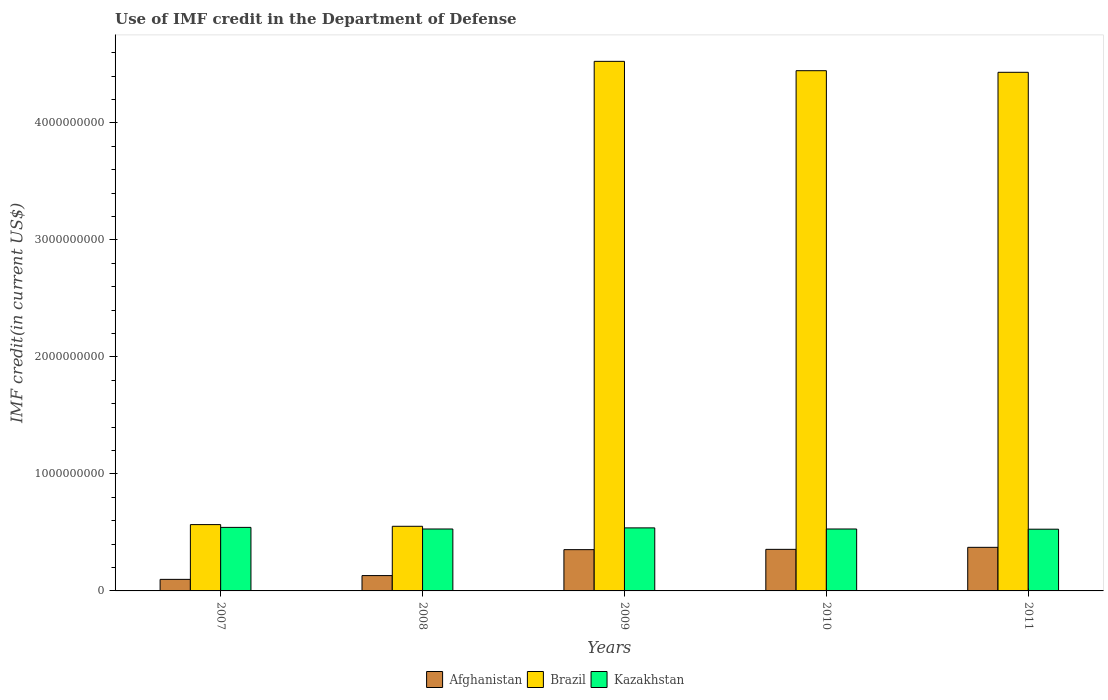Are the number of bars per tick equal to the number of legend labels?
Offer a very short reply. Yes. Are the number of bars on each tick of the X-axis equal?
Your answer should be very brief. Yes. What is the label of the 5th group of bars from the left?
Make the answer very short. 2011. In how many cases, is the number of bars for a given year not equal to the number of legend labels?
Provide a succinct answer. 0. What is the IMF credit in the Department of Defense in Afghanistan in 2007?
Your response must be concise. 9.88e+07. Across all years, what is the maximum IMF credit in the Department of Defense in Afghanistan?
Provide a succinct answer. 3.73e+08. Across all years, what is the minimum IMF credit in the Department of Defense in Brazil?
Your answer should be compact. 5.52e+08. What is the total IMF credit in the Department of Defense in Brazil in the graph?
Offer a very short reply. 1.45e+1. What is the difference between the IMF credit in the Department of Defense in Brazil in 2010 and that in 2011?
Give a very brief answer. 1.37e+07. What is the difference between the IMF credit in the Department of Defense in Brazil in 2007 and the IMF credit in the Department of Defense in Kazakhstan in 2010?
Make the answer very short. 3.76e+07. What is the average IMF credit in the Department of Defense in Afghanistan per year?
Make the answer very short. 2.62e+08. In the year 2010, what is the difference between the IMF credit in the Department of Defense in Afghanistan and IMF credit in the Department of Defense in Brazil?
Keep it short and to the point. -4.09e+09. What is the ratio of the IMF credit in the Department of Defense in Kazakhstan in 2007 to that in 2011?
Your answer should be compact. 1.03. Is the difference between the IMF credit in the Department of Defense in Afghanistan in 2010 and 2011 greater than the difference between the IMF credit in the Department of Defense in Brazil in 2010 and 2011?
Your answer should be compact. No. What is the difference between the highest and the second highest IMF credit in the Department of Defense in Afghanistan?
Your response must be concise. 1.73e+07. What is the difference between the highest and the lowest IMF credit in the Department of Defense in Afghanistan?
Provide a short and direct response. 2.74e+08. What does the 1st bar from the left in 2009 represents?
Offer a terse response. Afghanistan. What does the 3rd bar from the right in 2007 represents?
Offer a terse response. Afghanistan. Is it the case that in every year, the sum of the IMF credit in the Department of Defense in Afghanistan and IMF credit in the Department of Defense in Brazil is greater than the IMF credit in the Department of Defense in Kazakhstan?
Keep it short and to the point. Yes. How many bars are there?
Your answer should be compact. 15. How many years are there in the graph?
Your answer should be compact. 5. Does the graph contain any zero values?
Provide a short and direct response. No. How are the legend labels stacked?
Keep it short and to the point. Horizontal. What is the title of the graph?
Provide a succinct answer. Use of IMF credit in the Department of Defense. Does "South Sudan" appear as one of the legend labels in the graph?
Offer a very short reply. No. What is the label or title of the X-axis?
Offer a very short reply. Years. What is the label or title of the Y-axis?
Provide a short and direct response. IMF credit(in current US$). What is the IMF credit(in current US$) in Afghanistan in 2007?
Provide a succinct answer. 9.88e+07. What is the IMF credit(in current US$) in Brazil in 2007?
Provide a succinct answer. 5.67e+08. What is the IMF credit(in current US$) of Kazakhstan in 2007?
Give a very brief answer. 5.43e+08. What is the IMF credit(in current US$) in Afghanistan in 2008?
Your response must be concise. 1.31e+08. What is the IMF credit(in current US$) of Brazil in 2008?
Make the answer very short. 5.52e+08. What is the IMF credit(in current US$) of Kazakhstan in 2008?
Provide a short and direct response. 5.29e+08. What is the IMF credit(in current US$) in Afghanistan in 2009?
Provide a succinct answer. 3.53e+08. What is the IMF credit(in current US$) of Brazil in 2009?
Keep it short and to the point. 4.53e+09. What is the IMF credit(in current US$) of Kazakhstan in 2009?
Your answer should be compact. 5.39e+08. What is the IMF credit(in current US$) of Afghanistan in 2010?
Your answer should be very brief. 3.55e+08. What is the IMF credit(in current US$) in Brazil in 2010?
Your response must be concise. 4.45e+09. What is the IMF credit(in current US$) of Kazakhstan in 2010?
Your answer should be very brief. 5.29e+08. What is the IMF credit(in current US$) of Afghanistan in 2011?
Provide a short and direct response. 3.73e+08. What is the IMF credit(in current US$) of Brazil in 2011?
Offer a very short reply. 4.43e+09. What is the IMF credit(in current US$) in Kazakhstan in 2011?
Provide a short and direct response. 5.28e+08. Across all years, what is the maximum IMF credit(in current US$) of Afghanistan?
Your answer should be compact. 3.73e+08. Across all years, what is the maximum IMF credit(in current US$) of Brazil?
Your answer should be compact. 4.53e+09. Across all years, what is the maximum IMF credit(in current US$) of Kazakhstan?
Your answer should be very brief. 5.43e+08. Across all years, what is the minimum IMF credit(in current US$) of Afghanistan?
Your answer should be compact. 9.88e+07. Across all years, what is the minimum IMF credit(in current US$) of Brazil?
Offer a very short reply. 5.52e+08. Across all years, what is the minimum IMF credit(in current US$) of Kazakhstan?
Your answer should be compact. 5.28e+08. What is the total IMF credit(in current US$) of Afghanistan in the graph?
Ensure brevity in your answer.  1.31e+09. What is the total IMF credit(in current US$) of Brazil in the graph?
Your answer should be very brief. 1.45e+1. What is the total IMF credit(in current US$) of Kazakhstan in the graph?
Provide a short and direct response. 2.67e+09. What is the difference between the IMF credit(in current US$) of Afghanistan in 2007 and that in 2008?
Ensure brevity in your answer.  -3.23e+07. What is the difference between the IMF credit(in current US$) of Brazil in 2007 and that in 2008?
Keep it short and to the point. 1.43e+07. What is the difference between the IMF credit(in current US$) of Kazakhstan in 2007 and that in 2008?
Keep it short and to the point. 1.37e+07. What is the difference between the IMF credit(in current US$) in Afghanistan in 2007 and that in 2009?
Give a very brief answer. -2.54e+08. What is the difference between the IMF credit(in current US$) of Brazil in 2007 and that in 2009?
Your answer should be compact. -3.96e+09. What is the difference between the IMF credit(in current US$) of Kazakhstan in 2007 and that in 2009?
Provide a succinct answer. 4.32e+06. What is the difference between the IMF credit(in current US$) of Afghanistan in 2007 and that in 2010?
Your answer should be very brief. -2.56e+08. What is the difference between the IMF credit(in current US$) in Brazil in 2007 and that in 2010?
Offer a terse response. -3.88e+09. What is the difference between the IMF credit(in current US$) of Kazakhstan in 2007 and that in 2010?
Make the answer very short. 1.38e+07. What is the difference between the IMF credit(in current US$) in Afghanistan in 2007 and that in 2011?
Provide a succinct answer. -2.74e+08. What is the difference between the IMF credit(in current US$) in Brazil in 2007 and that in 2011?
Give a very brief answer. -3.87e+09. What is the difference between the IMF credit(in current US$) of Kazakhstan in 2007 and that in 2011?
Provide a succinct answer. 1.55e+07. What is the difference between the IMF credit(in current US$) in Afghanistan in 2008 and that in 2009?
Your response must be concise. -2.22e+08. What is the difference between the IMF credit(in current US$) of Brazil in 2008 and that in 2009?
Offer a terse response. -3.97e+09. What is the difference between the IMF credit(in current US$) of Kazakhstan in 2008 and that in 2009?
Make the answer very short. -9.42e+06. What is the difference between the IMF credit(in current US$) of Afghanistan in 2008 and that in 2010?
Offer a terse response. -2.24e+08. What is the difference between the IMF credit(in current US$) of Brazil in 2008 and that in 2010?
Make the answer very short. -3.89e+09. What is the difference between the IMF credit(in current US$) of Kazakhstan in 2008 and that in 2010?
Provide a short and direct response. 8.20e+04. What is the difference between the IMF credit(in current US$) of Afghanistan in 2008 and that in 2011?
Make the answer very short. -2.41e+08. What is the difference between the IMF credit(in current US$) of Brazil in 2008 and that in 2011?
Make the answer very short. -3.88e+09. What is the difference between the IMF credit(in current US$) of Kazakhstan in 2008 and that in 2011?
Ensure brevity in your answer.  1.72e+06. What is the difference between the IMF credit(in current US$) of Afghanistan in 2009 and that in 2010?
Offer a terse response. -2.48e+06. What is the difference between the IMF credit(in current US$) in Brazil in 2009 and that in 2010?
Keep it short and to the point. 7.99e+07. What is the difference between the IMF credit(in current US$) in Kazakhstan in 2009 and that in 2010?
Ensure brevity in your answer.  9.50e+06. What is the difference between the IMF credit(in current US$) in Afghanistan in 2009 and that in 2011?
Provide a succinct answer. -1.98e+07. What is the difference between the IMF credit(in current US$) in Brazil in 2009 and that in 2011?
Keep it short and to the point. 9.36e+07. What is the difference between the IMF credit(in current US$) of Kazakhstan in 2009 and that in 2011?
Ensure brevity in your answer.  1.11e+07. What is the difference between the IMF credit(in current US$) of Afghanistan in 2010 and that in 2011?
Give a very brief answer. -1.73e+07. What is the difference between the IMF credit(in current US$) of Brazil in 2010 and that in 2011?
Provide a short and direct response. 1.37e+07. What is the difference between the IMF credit(in current US$) in Kazakhstan in 2010 and that in 2011?
Give a very brief answer. 1.64e+06. What is the difference between the IMF credit(in current US$) of Afghanistan in 2007 and the IMF credit(in current US$) of Brazil in 2008?
Your answer should be compact. -4.54e+08. What is the difference between the IMF credit(in current US$) in Afghanistan in 2007 and the IMF credit(in current US$) in Kazakhstan in 2008?
Provide a short and direct response. -4.31e+08. What is the difference between the IMF credit(in current US$) in Brazil in 2007 and the IMF credit(in current US$) in Kazakhstan in 2008?
Give a very brief answer. 3.75e+07. What is the difference between the IMF credit(in current US$) in Afghanistan in 2007 and the IMF credit(in current US$) in Brazil in 2009?
Your answer should be very brief. -4.43e+09. What is the difference between the IMF credit(in current US$) of Afghanistan in 2007 and the IMF credit(in current US$) of Kazakhstan in 2009?
Offer a very short reply. -4.40e+08. What is the difference between the IMF credit(in current US$) in Brazil in 2007 and the IMF credit(in current US$) in Kazakhstan in 2009?
Make the answer very short. 2.80e+07. What is the difference between the IMF credit(in current US$) of Afghanistan in 2007 and the IMF credit(in current US$) of Brazil in 2010?
Your response must be concise. -4.35e+09. What is the difference between the IMF credit(in current US$) in Afghanistan in 2007 and the IMF credit(in current US$) in Kazakhstan in 2010?
Offer a terse response. -4.30e+08. What is the difference between the IMF credit(in current US$) in Brazil in 2007 and the IMF credit(in current US$) in Kazakhstan in 2010?
Your answer should be very brief. 3.76e+07. What is the difference between the IMF credit(in current US$) of Afghanistan in 2007 and the IMF credit(in current US$) of Brazil in 2011?
Keep it short and to the point. -4.33e+09. What is the difference between the IMF credit(in current US$) in Afghanistan in 2007 and the IMF credit(in current US$) in Kazakhstan in 2011?
Offer a very short reply. -4.29e+08. What is the difference between the IMF credit(in current US$) of Brazil in 2007 and the IMF credit(in current US$) of Kazakhstan in 2011?
Your answer should be compact. 3.92e+07. What is the difference between the IMF credit(in current US$) of Afghanistan in 2008 and the IMF credit(in current US$) of Brazil in 2009?
Make the answer very short. -4.39e+09. What is the difference between the IMF credit(in current US$) in Afghanistan in 2008 and the IMF credit(in current US$) in Kazakhstan in 2009?
Offer a very short reply. -4.08e+08. What is the difference between the IMF credit(in current US$) in Brazil in 2008 and the IMF credit(in current US$) in Kazakhstan in 2009?
Give a very brief answer. 1.37e+07. What is the difference between the IMF credit(in current US$) in Afghanistan in 2008 and the IMF credit(in current US$) in Brazil in 2010?
Provide a succinct answer. -4.32e+09. What is the difference between the IMF credit(in current US$) in Afghanistan in 2008 and the IMF credit(in current US$) in Kazakhstan in 2010?
Provide a succinct answer. -3.98e+08. What is the difference between the IMF credit(in current US$) of Brazil in 2008 and the IMF credit(in current US$) of Kazakhstan in 2010?
Make the answer very short. 2.32e+07. What is the difference between the IMF credit(in current US$) of Afghanistan in 2008 and the IMF credit(in current US$) of Brazil in 2011?
Your answer should be very brief. -4.30e+09. What is the difference between the IMF credit(in current US$) of Afghanistan in 2008 and the IMF credit(in current US$) of Kazakhstan in 2011?
Provide a short and direct response. -3.97e+08. What is the difference between the IMF credit(in current US$) in Brazil in 2008 and the IMF credit(in current US$) in Kazakhstan in 2011?
Provide a short and direct response. 2.48e+07. What is the difference between the IMF credit(in current US$) in Afghanistan in 2009 and the IMF credit(in current US$) in Brazil in 2010?
Your answer should be very brief. -4.09e+09. What is the difference between the IMF credit(in current US$) in Afghanistan in 2009 and the IMF credit(in current US$) in Kazakhstan in 2010?
Keep it short and to the point. -1.76e+08. What is the difference between the IMF credit(in current US$) in Brazil in 2009 and the IMF credit(in current US$) in Kazakhstan in 2010?
Offer a terse response. 4.00e+09. What is the difference between the IMF credit(in current US$) in Afghanistan in 2009 and the IMF credit(in current US$) in Brazil in 2011?
Your answer should be very brief. -4.08e+09. What is the difference between the IMF credit(in current US$) in Afghanistan in 2009 and the IMF credit(in current US$) in Kazakhstan in 2011?
Your answer should be compact. -1.75e+08. What is the difference between the IMF credit(in current US$) of Brazil in 2009 and the IMF credit(in current US$) of Kazakhstan in 2011?
Ensure brevity in your answer.  4.00e+09. What is the difference between the IMF credit(in current US$) of Afghanistan in 2010 and the IMF credit(in current US$) of Brazil in 2011?
Provide a short and direct response. -4.08e+09. What is the difference between the IMF credit(in current US$) in Afghanistan in 2010 and the IMF credit(in current US$) in Kazakhstan in 2011?
Your answer should be compact. -1.72e+08. What is the difference between the IMF credit(in current US$) in Brazil in 2010 and the IMF credit(in current US$) in Kazakhstan in 2011?
Offer a terse response. 3.92e+09. What is the average IMF credit(in current US$) in Afghanistan per year?
Provide a short and direct response. 2.62e+08. What is the average IMF credit(in current US$) in Brazil per year?
Your answer should be very brief. 2.90e+09. What is the average IMF credit(in current US$) of Kazakhstan per year?
Offer a terse response. 5.34e+08. In the year 2007, what is the difference between the IMF credit(in current US$) of Afghanistan and IMF credit(in current US$) of Brazil?
Make the answer very short. -4.68e+08. In the year 2007, what is the difference between the IMF credit(in current US$) of Afghanistan and IMF credit(in current US$) of Kazakhstan?
Keep it short and to the point. -4.44e+08. In the year 2007, what is the difference between the IMF credit(in current US$) of Brazil and IMF credit(in current US$) of Kazakhstan?
Ensure brevity in your answer.  2.37e+07. In the year 2008, what is the difference between the IMF credit(in current US$) of Afghanistan and IMF credit(in current US$) of Brazil?
Keep it short and to the point. -4.21e+08. In the year 2008, what is the difference between the IMF credit(in current US$) of Afghanistan and IMF credit(in current US$) of Kazakhstan?
Keep it short and to the point. -3.98e+08. In the year 2008, what is the difference between the IMF credit(in current US$) in Brazil and IMF credit(in current US$) in Kazakhstan?
Your response must be concise. 2.31e+07. In the year 2009, what is the difference between the IMF credit(in current US$) in Afghanistan and IMF credit(in current US$) in Brazil?
Make the answer very short. -4.17e+09. In the year 2009, what is the difference between the IMF credit(in current US$) in Afghanistan and IMF credit(in current US$) in Kazakhstan?
Your answer should be compact. -1.86e+08. In the year 2009, what is the difference between the IMF credit(in current US$) in Brazil and IMF credit(in current US$) in Kazakhstan?
Provide a short and direct response. 3.99e+09. In the year 2010, what is the difference between the IMF credit(in current US$) of Afghanistan and IMF credit(in current US$) of Brazil?
Provide a succinct answer. -4.09e+09. In the year 2010, what is the difference between the IMF credit(in current US$) in Afghanistan and IMF credit(in current US$) in Kazakhstan?
Offer a very short reply. -1.74e+08. In the year 2010, what is the difference between the IMF credit(in current US$) of Brazil and IMF credit(in current US$) of Kazakhstan?
Your response must be concise. 3.92e+09. In the year 2011, what is the difference between the IMF credit(in current US$) in Afghanistan and IMF credit(in current US$) in Brazil?
Ensure brevity in your answer.  -4.06e+09. In the year 2011, what is the difference between the IMF credit(in current US$) of Afghanistan and IMF credit(in current US$) of Kazakhstan?
Your answer should be compact. -1.55e+08. In the year 2011, what is the difference between the IMF credit(in current US$) in Brazil and IMF credit(in current US$) in Kazakhstan?
Ensure brevity in your answer.  3.90e+09. What is the ratio of the IMF credit(in current US$) in Afghanistan in 2007 to that in 2008?
Ensure brevity in your answer.  0.75. What is the ratio of the IMF credit(in current US$) in Kazakhstan in 2007 to that in 2008?
Your answer should be compact. 1.03. What is the ratio of the IMF credit(in current US$) of Afghanistan in 2007 to that in 2009?
Ensure brevity in your answer.  0.28. What is the ratio of the IMF credit(in current US$) in Brazil in 2007 to that in 2009?
Your answer should be compact. 0.13. What is the ratio of the IMF credit(in current US$) in Kazakhstan in 2007 to that in 2009?
Your answer should be very brief. 1.01. What is the ratio of the IMF credit(in current US$) in Afghanistan in 2007 to that in 2010?
Offer a very short reply. 0.28. What is the ratio of the IMF credit(in current US$) of Brazil in 2007 to that in 2010?
Give a very brief answer. 0.13. What is the ratio of the IMF credit(in current US$) in Kazakhstan in 2007 to that in 2010?
Give a very brief answer. 1.03. What is the ratio of the IMF credit(in current US$) in Afghanistan in 2007 to that in 2011?
Your response must be concise. 0.27. What is the ratio of the IMF credit(in current US$) in Brazil in 2007 to that in 2011?
Keep it short and to the point. 0.13. What is the ratio of the IMF credit(in current US$) of Kazakhstan in 2007 to that in 2011?
Your response must be concise. 1.03. What is the ratio of the IMF credit(in current US$) in Afghanistan in 2008 to that in 2009?
Give a very brief answer. 0.37. What is the ratio of the IMF credit(in current US$) of Brazil in 2008 to that in 2009?
Your answer should be very brief. 0.12. What is the ratio of the IMF credit(in current US$) in Kazakhstan in 2008 to that in 2009?
Keep it short and to the point. 0.98. What is the ratio of the IMF credit(in current US$) in Afghanistan in 2008 to that in 2010?
Ensure brevity in your answer.  0.37. What is the ratio of the IMF credit(in current US$) in Brazil in 2008 to that in 2010?
Offer a terse response. 0.12. What is the ratio of the IMF credit(in current US$) in Kazakhstan in 2008 to that in 2010?
Your response must be concise. 1. What is the ratio of the IMF credit(in current US$) of Afghanistan in 2008 to that in 2011?
Your response must be concise. 0.35. What is the ratio of the IMF credit(in current US$) of Brazil in 2008 to that in 2011?
Your answer should be compact. 0.12. What is the ratio of the IMF credit(in current US$) of Kazakhstan in 2008 to that in 2011?
Keep it short and to the point. 1. What is the ratio of the IMF credit(in current US$) of Afghanistan in 2009 to that in 2010?
Make the answer very short. 0.99. What is the ratio of the IMF credit(in current US$) of Brazil in 2009 to that in 2010?
Provide a short and direct response. 1.02. What is the ratio of the IMF credit(in current US$) of Kazakhstan in 2009 to that in 2010?
Give a very brief answer. 1.02. What is the ratio of the IMF credit(in current US$) of Afghanistan in 2009 to that in 2011?
Your answer should be very brief. 0.95. What is the ratio of the IMF credit(in current US$) in Brazil in 2009 to that in 2011?
Provide a short and direct response. 1.02. What is the ratio of the IMF credit(in current US$) in Kazakhstan in 2009 to that in 2011?
Make the answer very short. 1.02. What is the ratio of the IMF credit(in current US$) of Afghanistan in 2010 to that in 2011?
Offer a very short reply. 0.95. What is the difference between the highest and the second highest IMF credit(in current US$) in Afghanistan?
Offer a terse response. 1.73e+07. What is the difference between the highest and the second highest IMF credit(in current US$) in Brazil?
Your response must be concise. 7.99e+07. What is the difference between the highest and the second highest IMF credit(in current US$) of Kazakhstan?
Provide a short and direct response. 4.32e+06. What is the difference between the highest and the lowest IMF credit(in current US$) in Afghanistan?
Make the answer very short. 2.74e+08. What is the difference between the highest and the lowest IMF credit(in current US$) of Brazil?
Give a very brief answer. 3.97e+09. What is the difference between the highest and the lowest IMF credit(in current US$) of Kazakhstan?
Your answer should be very brief. 1.55e+07. 